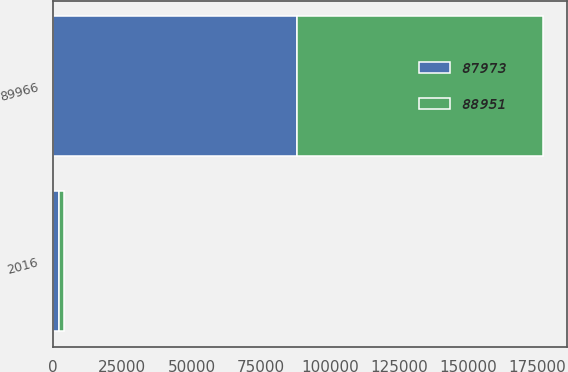Convert chart to OTSL. <chart><loc_0><loc_0><loc_500><loc_500><stacked_bar_chart><ecel><fcel>2016<fcel>89966<nl><fcel>87973<fcel>2015<fcel>87973<nl><fcel>88951<fcel>2014<fcel>88951<nl></chart> 